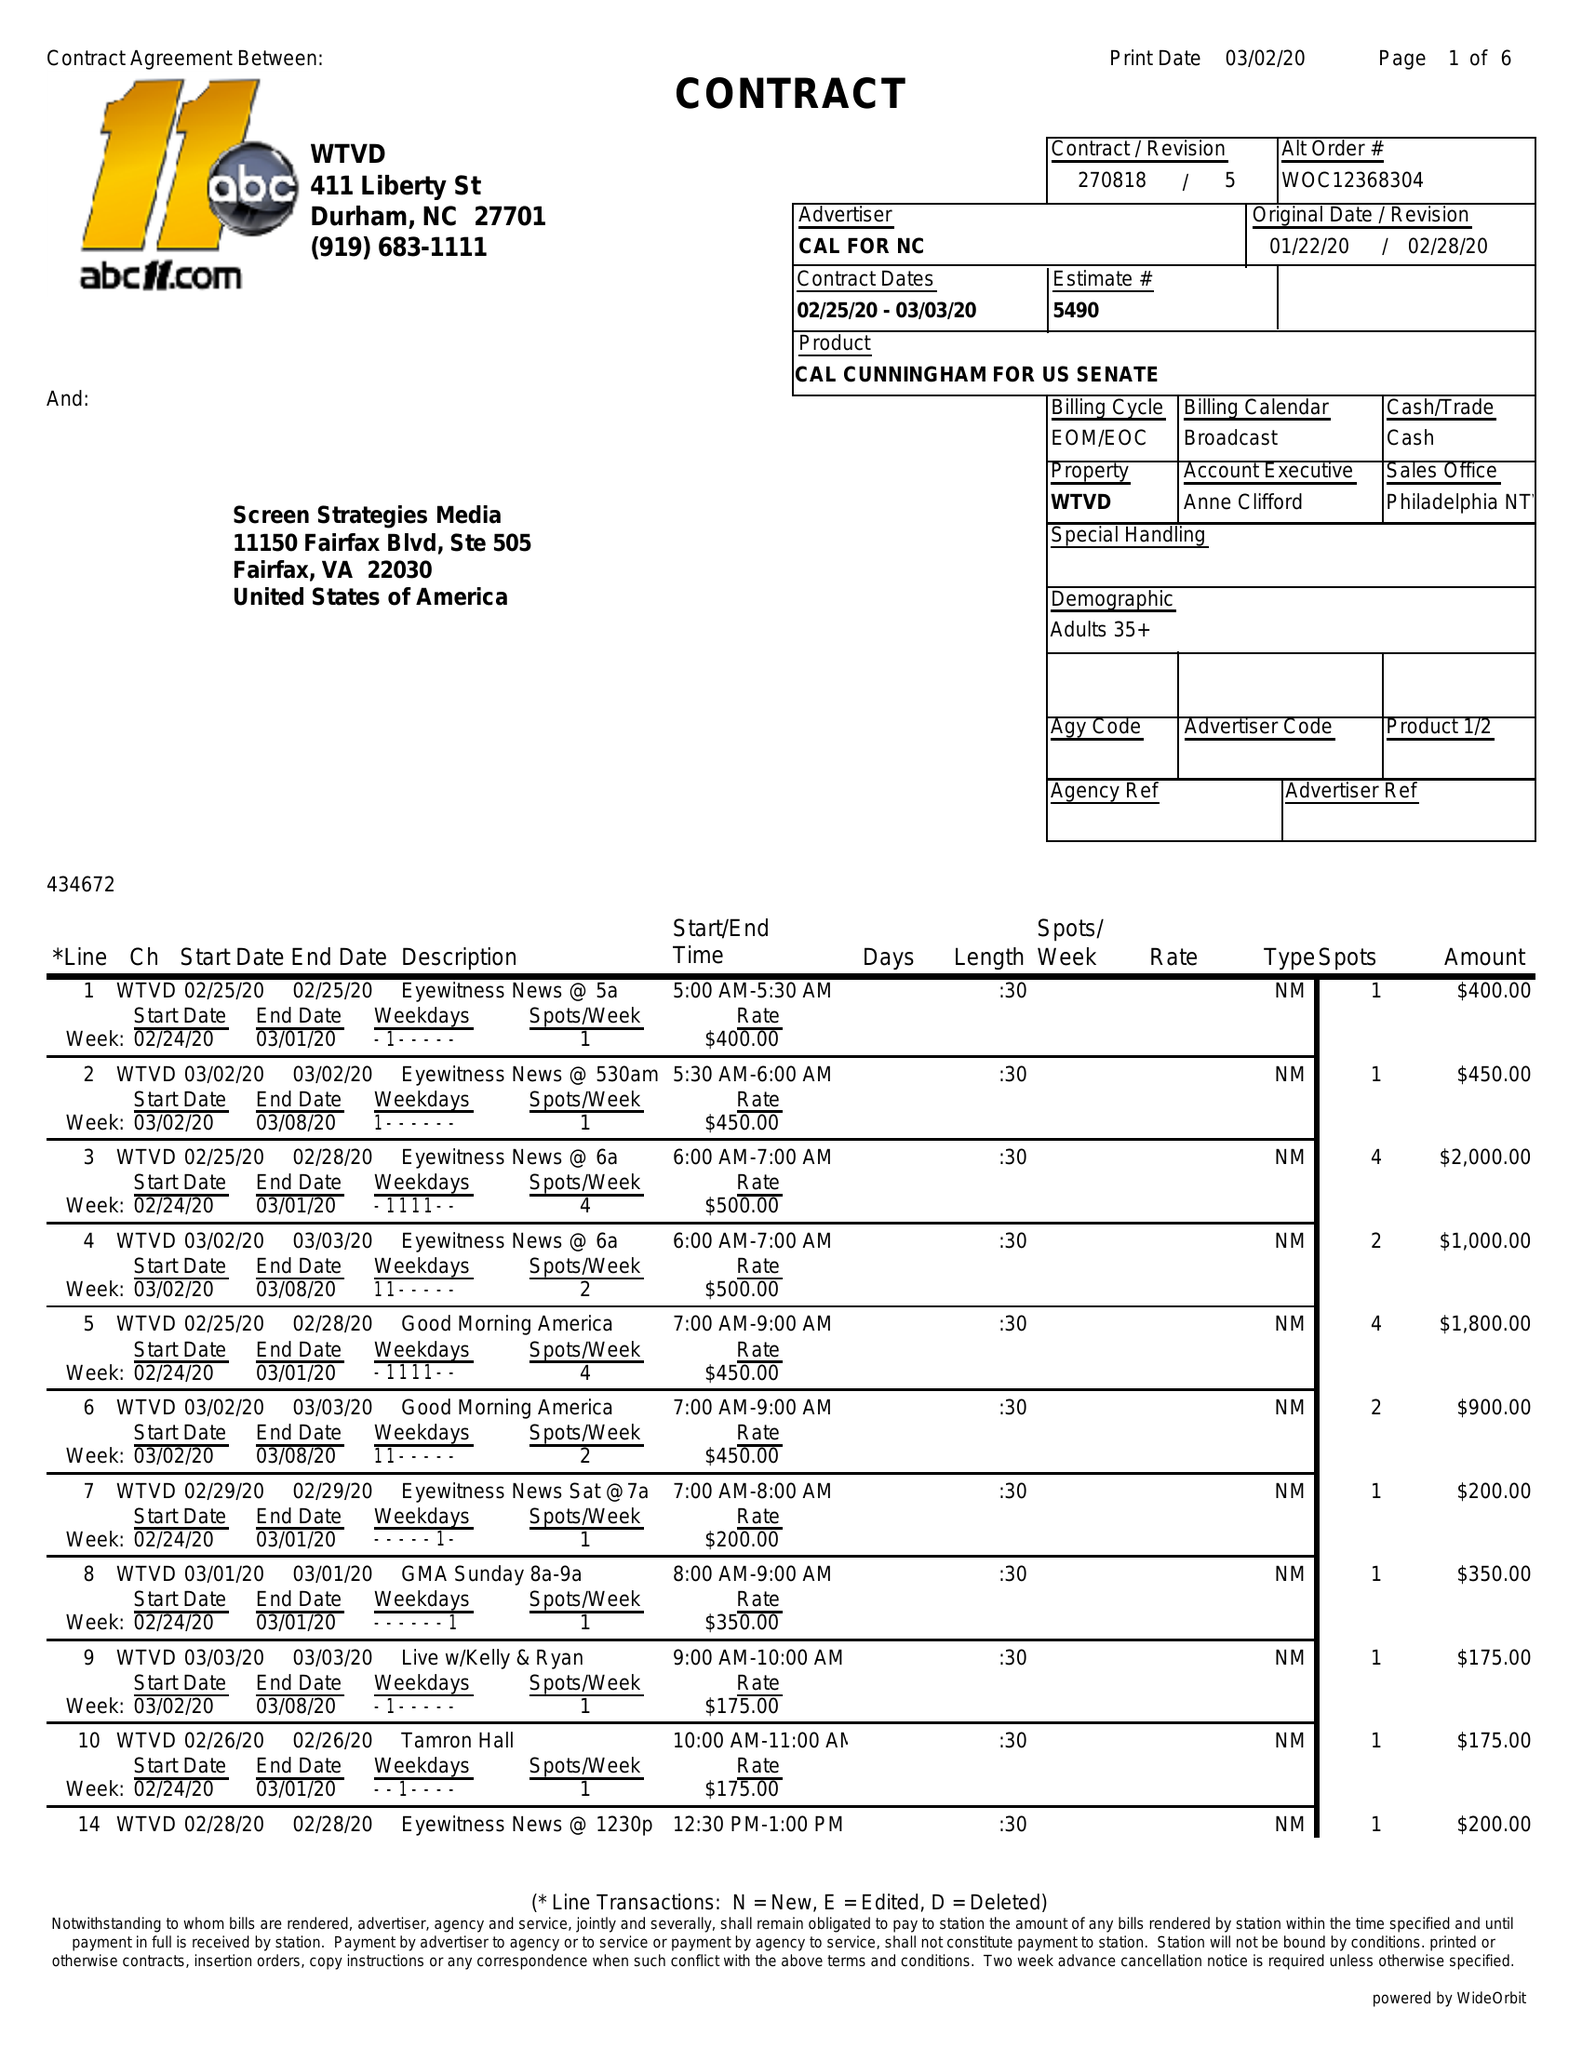What is the value for the flight_from?
Answer the question using a single word or phrase. 02/25/20 